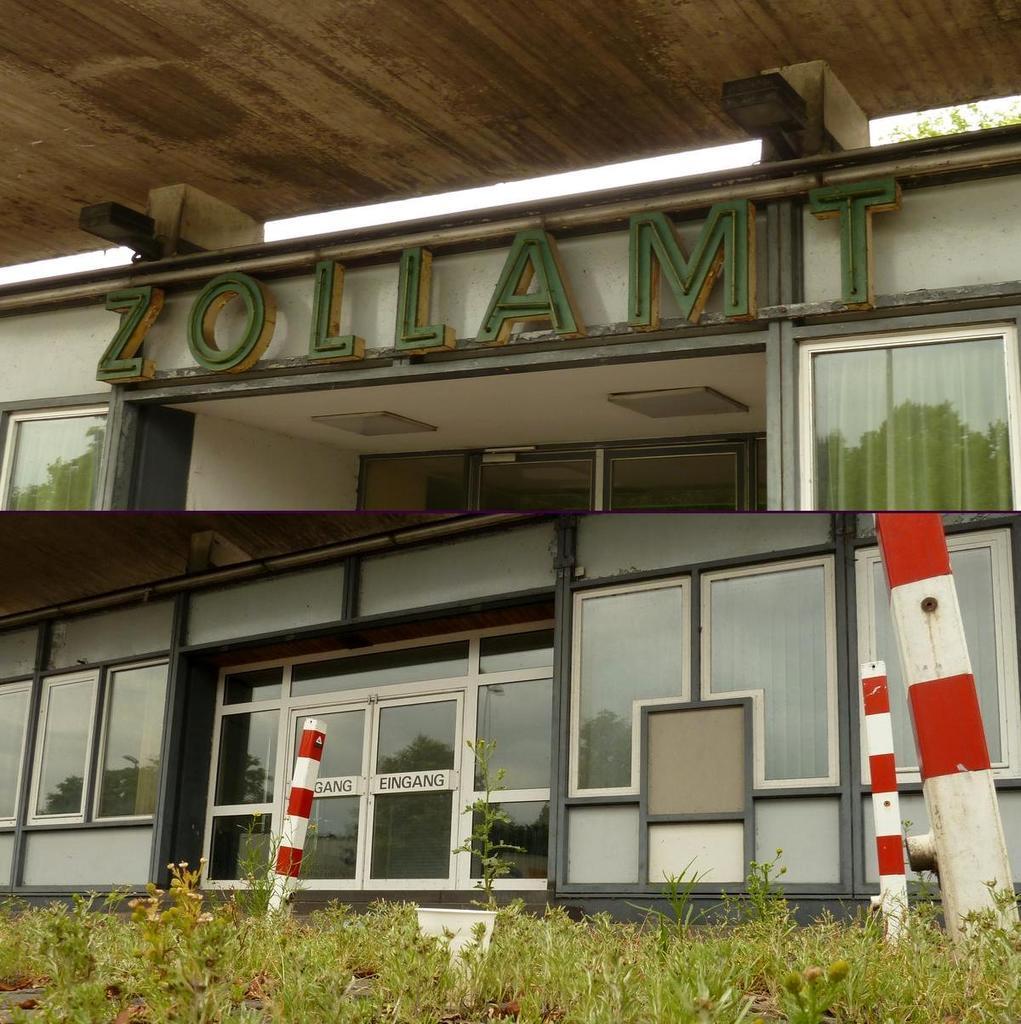How would you summarize this image in a sentence or two? In the image there are plants in the foreground and behind the plants there is a building, there is a roof above the building. 